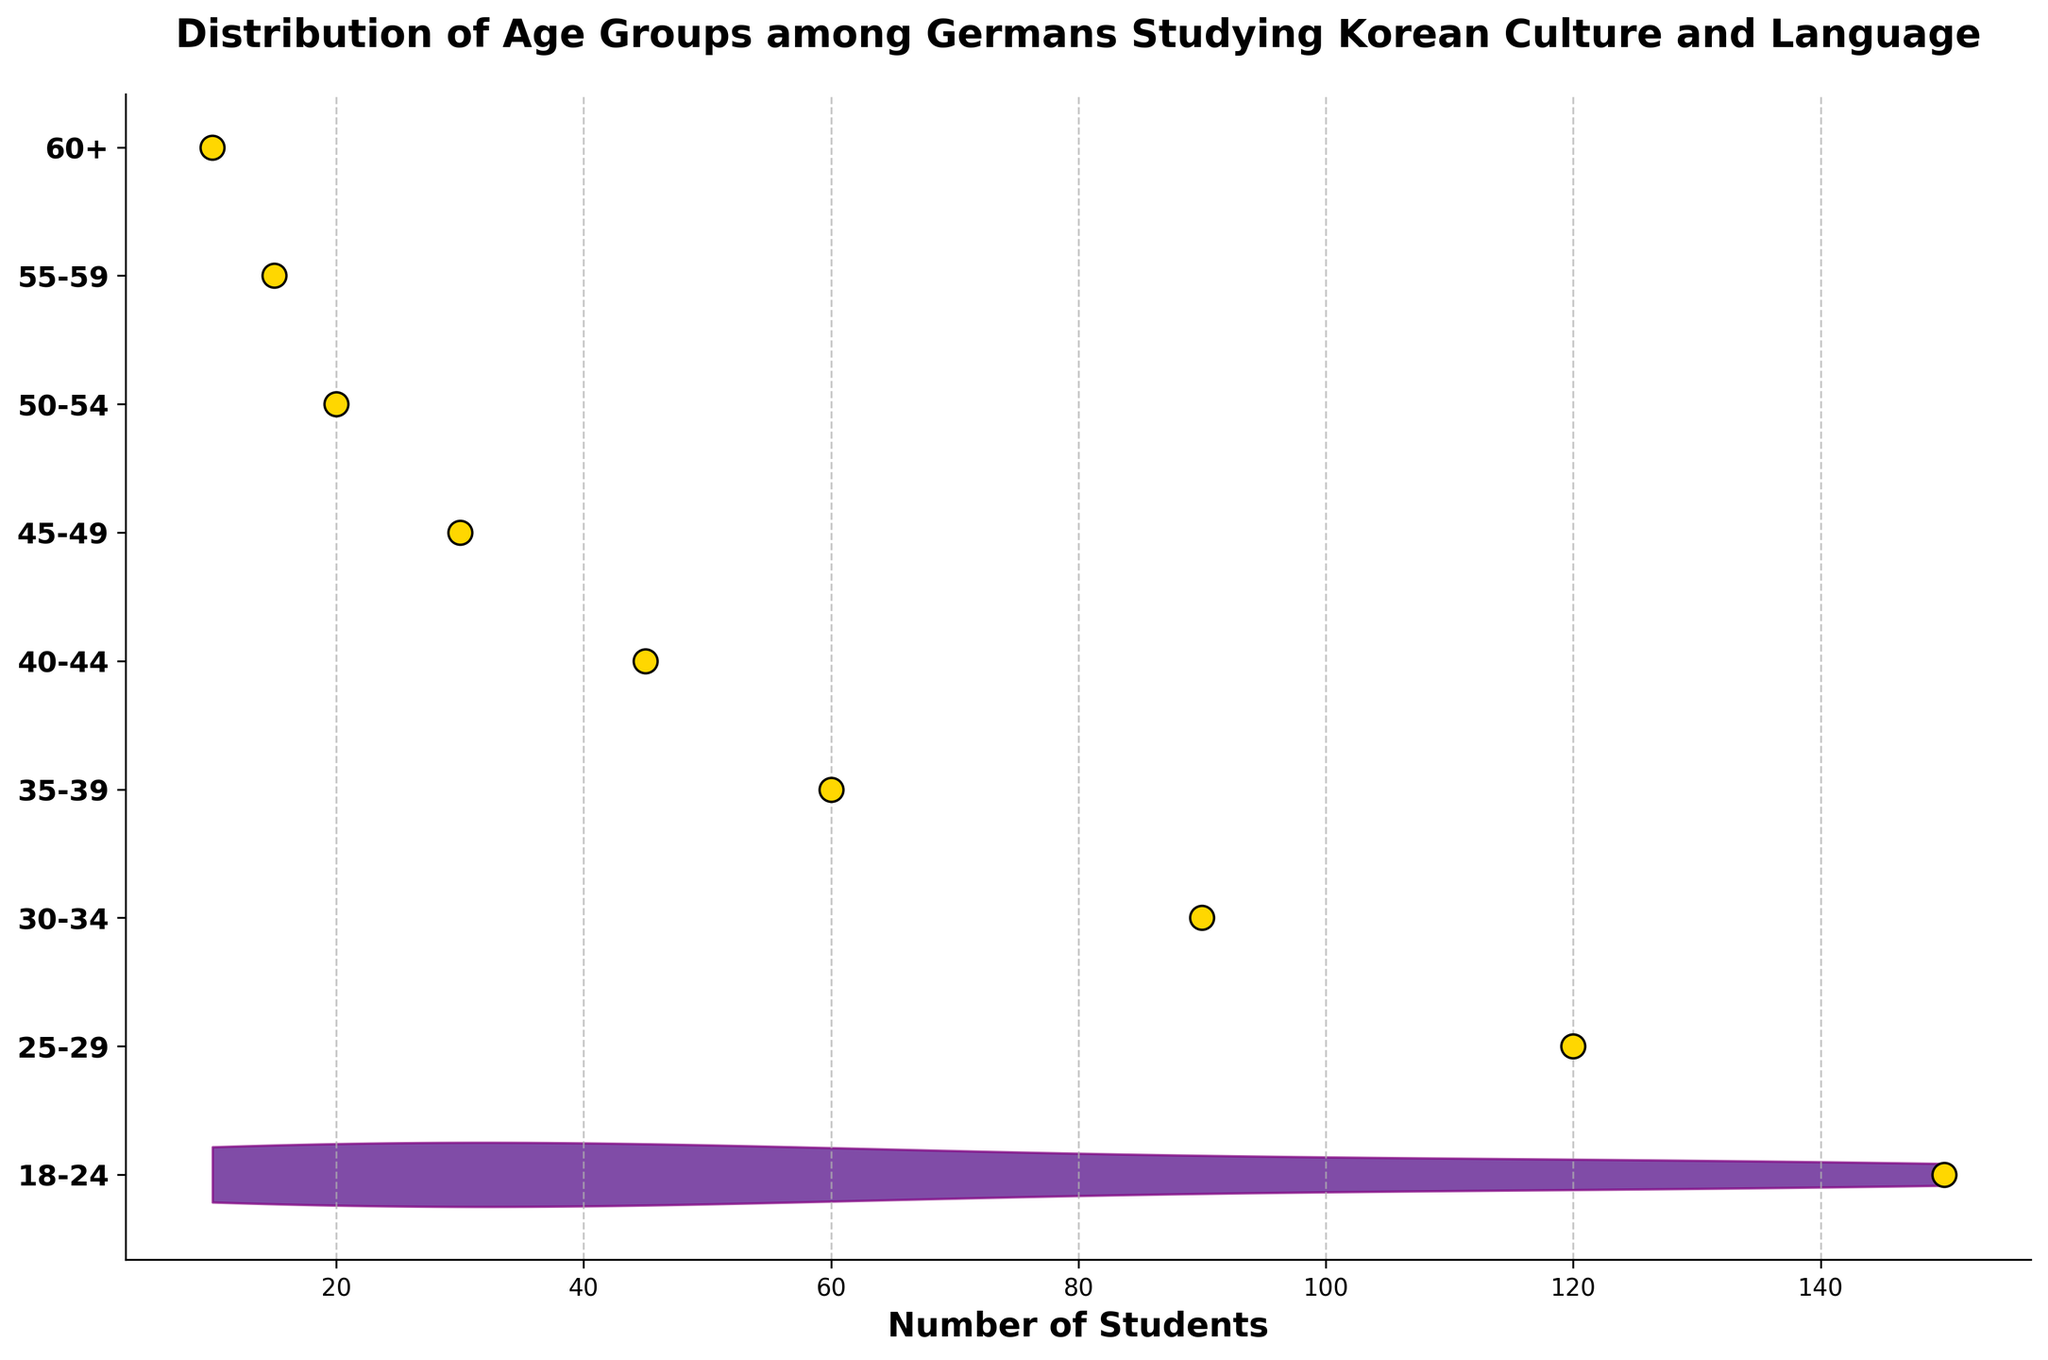What's the title of the figure? The title of the figure is displayed prominently at the top of the plot. The title is "Distribution of Age Groups among Germans Studying Korean Culture and Language".
Answer: Distribution of Age Groups among Germans Studying Korean Culture and Language What is the age group with the highest number of students? By looking at the scatter points and the spread of the largest violin plot, it is clear that the age group 18-24 has the highest number of students.
Answer: 18-24 Count the number of age groups displayed in the plot. There are labels on the y-axis representing different age groups. Counting these labels yields a total of 9 age groups.
Answer: 9 How does the number of students in the 25-29 age group compare to the 50-54 age group? The scatter plot shows that the 25-29 age group has 120 students while the 50-54 age group has 20 students. Comparing these numbers, the 25-29 age group has significantly more students.
Answer: 25-29 has more students What is the total number of students across all age groups? To find the total number of students, sum the numbers from all age groups: 150 (18-24) + 120 (25-29) + 90 (30-34) + 60 (35-39) + 45 (40-44) + 30 (45-49) + 20 (50-54) + 15 (55-59) + 10 (60+) = 540.
Answer: 540 Which age group has the smallest number of students, and how many students are in that group? By observing the scatter points and violin plots, the smallest number is in the 60+ age group, which has 10 students.
Answer: 60+, 10 Is the number of students above or below 50 for the age group 40-44? The scatter point for the 40-44 age group shows that the number of students is 45, which is below 50.
Answer: Below 50 What color are the scatter points representing individual data points? The scatter points that represent individual data points are colored gold with black edges.
Answer: Gold with black edges Do any of the age groups have an equal number of students? By looking at the scatter points, we observe that all groups have differing numbers of students; no two groups have the same count.
Answer: No How does the distribution of students change as the age increases? From the scatter plot and violin width, we observe that the number of students decreases as the age increases. The widest violin plot and highest scatter points appear in younger age groups, and they gradually narrow and decrease in higher age groups.
Answer: Decreases 